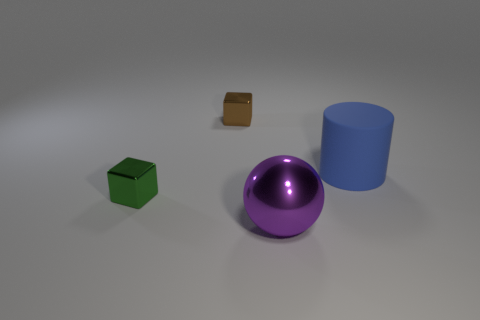What is the blue cylinder made of?
Provide a succinct answer. Rubber. What is the size of the green object that is the same shape as the brown shiny object?
Make the answer very short. Small. What number of other things are there of the same material as the big purple ball
Your answer should be compact. 2. Is the tiny green cube made of the same material as the big object that is on the right side of the large metallic thing?
Give a very brief answer. No. Are there fewer purple balls in front of the big ball than brown objects behind the green shiny object?
Provide a short and direct response. Yes. What is the color of the tiny cube in front of the matte cylinder?
Make the answer very short. Green. What number of other things are there of the same color as the shiny sphere?
Provide a short and direct response. 0. Does the metallic thing that is in front of the green object have the same size as the tiny brown thing?
Provide a short and direct response. No. What number of green metallic things are behind the big purple object?
Keep it short and to the point. 1. Are there any other objects of the same size as the green thing?
Provide a short and direct response. Yes. 